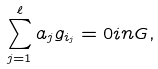<formula> <loc_0><loc_0><loc_500><loc_500>\sum _ { j = 1 } ^ { \ell } a _ { j } g _ { i _ { j } } = 0 i n G ,</formula> 